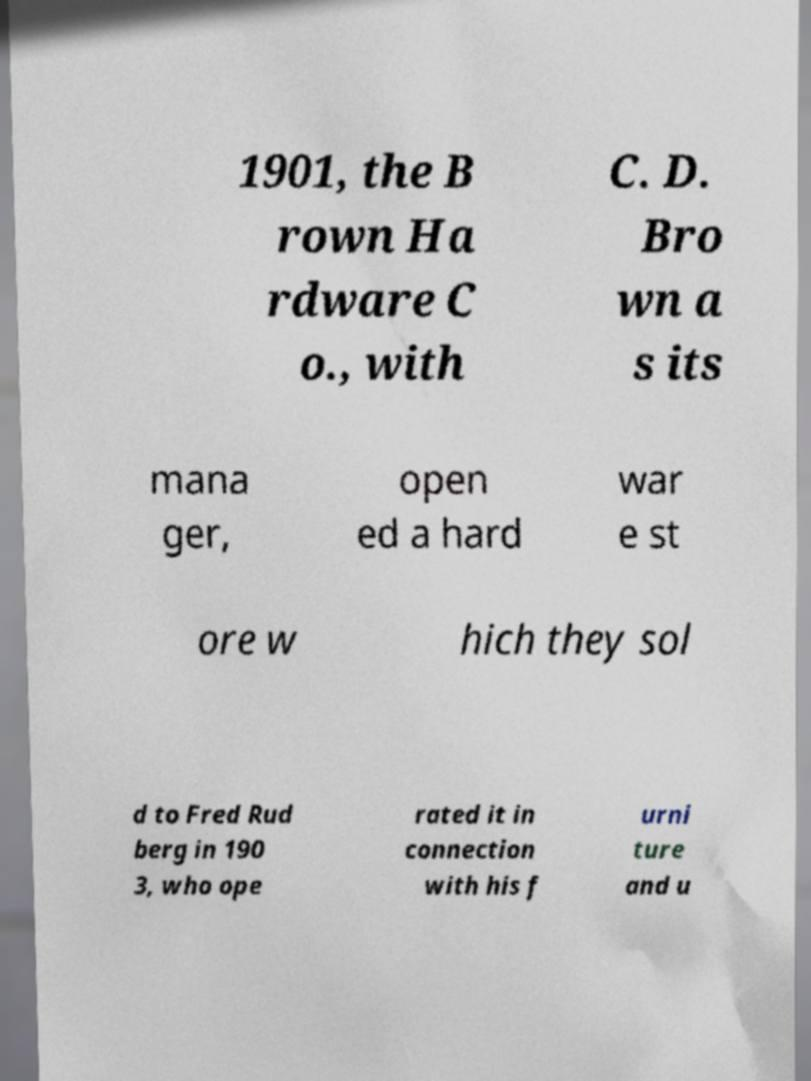Please identify and transcribe the text found in this image. 1901, the B rown Ha rdware C o., with C. D. Bro wn a s its mana ger, open ed a hard war e st ore w hich they sol d to Fred Rud berg in 190 3, who ope rated it in connection with his f urni ture and u 